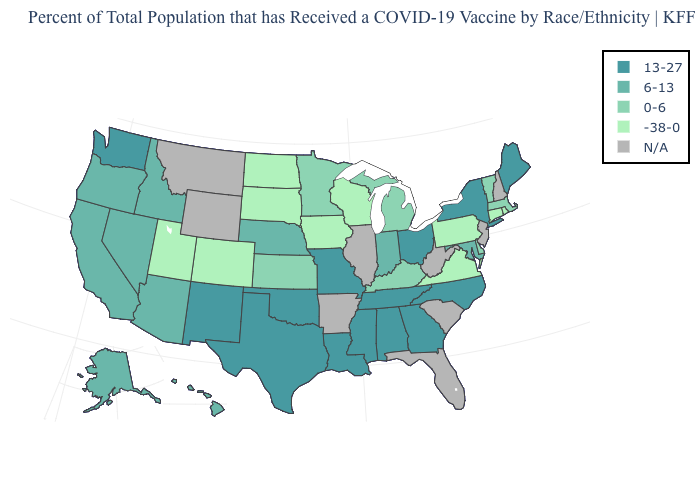Which states have the highest value in the USA?
Quick response, please. Alabama, Georgia, Louisiana, Maine, Mississippi, Missouri, New Mexico, New York, North Carolina, Ohio, Oklahoma, Tennessee, Texas, Washington. What is the value of Pennsylvania?
Short answer required. -38-0. What is the value of Hawaii?
Be succinct. 6-13. What is the value of Kentucky?
Answer briefly. 0-6. Name the states that have a value in the range 0-6?
Short answer required. Delaware, Kansas, Kentucky, Massachusetts, Michigan, Minnesota, Vermont. What is the value of Idaho?
Answer briefly. 6-13. Name the states that have a value in the range N/A?
Write a very short answer. Arkansas, Florida, Illinois, Montana, New Hampshire, New Jersey, South Carolina, West Virginia, Wyoming. Among the states that border Massachusetts , does Connecticut have the lowest value?
Write a very short answer. Yes. What is the value of Arkansas?
Give a very brief answer. N/A. Does Pennsylvania have the lowest value in the Northeast?
Give a very brief answer. Yes. Does the first symbol in the legend represent the smallest category?
Answer briefly. No. Name the states that have a value in the range 13-27?
Give a very brief answer. Alabama, Georgia, Louisiana, Maine, Mississippi, Missouri, New Mexico, New York, North Carolina, Ohio, Oklahoma, Tennessee, Texas, Washington. Name the states that have a value in the range 13-27?
Write a very short answer. Alabama, Georgia, Louisiana, Maine, Mississippi, Missouri, New Mexico, New York, North Carolina, Ohio, Oklahoma, Tennessee, Texas, Washington. 